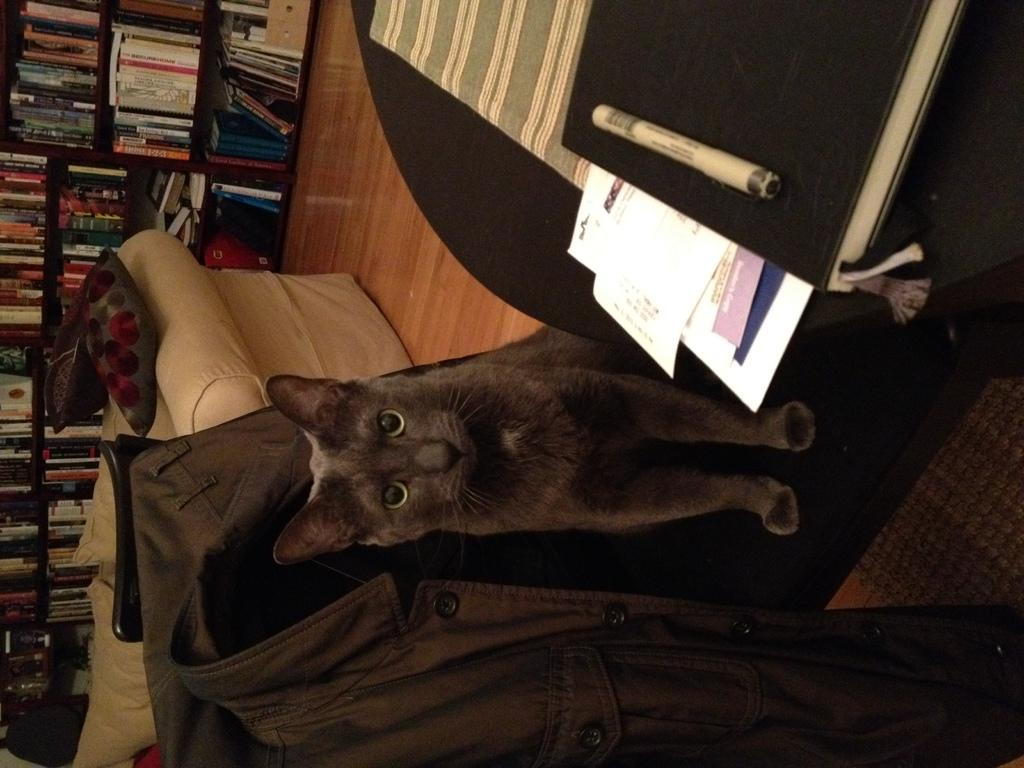What type of animal is in the image? There is a cat in the image. Where is the cat located in the image? The cat is sitting on a chair. What is the color of the cat? The cat is black in color. What items can be seen on the table in the image? There is a book and paper on the table. What can be seen in the background of the image? There are books in a rack in the background. What type of protest is the cat participating in the image? There is no protest present in the image; it features a cat sitting on a chair. Can you tell me how many zebras are visible in the image? There are no zebras present in the image. 